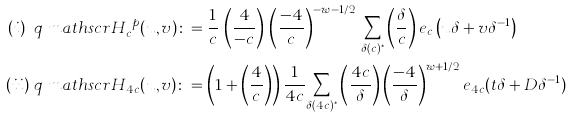<formula> <loc_0><loc_0><loc_500><loc_500>( i ) \ q & { \ m a t h s c r { H } } ^ { \ p } _ { c } ( u , v ) \colon = \frac { 1 } { c } \, \left ( \frac { 4 } { - c } \right ) \, \left ( \frac { - 4 } { c } \right ) ^ { - w - 1 / 2 } \, \underset { \delta ( c ) ^ { * } } \sum \left ( \frac { \delta } { c } \right ) e _ { c } \left ( u \delta + v \delta ^ { - 1 } \right ) \\ ( i i ) \ q & \ m a t h s c r { H } _ { 4 c } ( u , v ) \colon = \left ( 1 + \left ( \frac { 4 } { c } \right ) \right ) \frac { 1 } { 4 c } \underset { \delta ( 4 c ) ^ { * } } \sum \left ( \frac { 4 c } { \delta } \right ) \left ( \frac { - 4 } { \delta } \right ) ^ { w + 1 / 2 } e _ { 4 c } ( t \delta + D \delta ^ { - 1 } )</formula> 